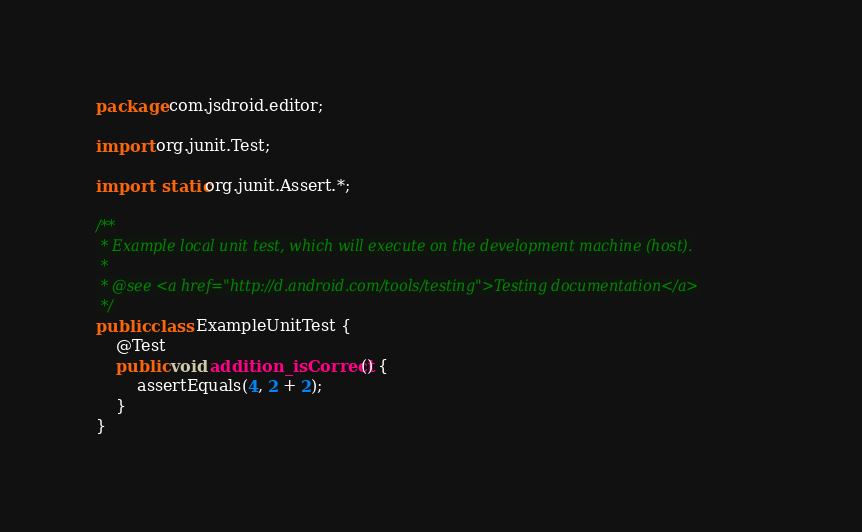<code> <loc_0><loc_0><loc_500><loc_500><_Java_>package com.jsdroid.editor;

import org.junit.Test;

import static org.junit.Assert.*;

/**
 * Example local unit test, which will execute on the development machine (host).
 *
 * @see <a href="http://d.android.com/tools/testing">Testing documentation</a>
 */
public class ExampleUnitTest {
    @Test
    public void addition_isCorrect() {
        assertEquals(4, 2 + 2);
    }
}</code> 